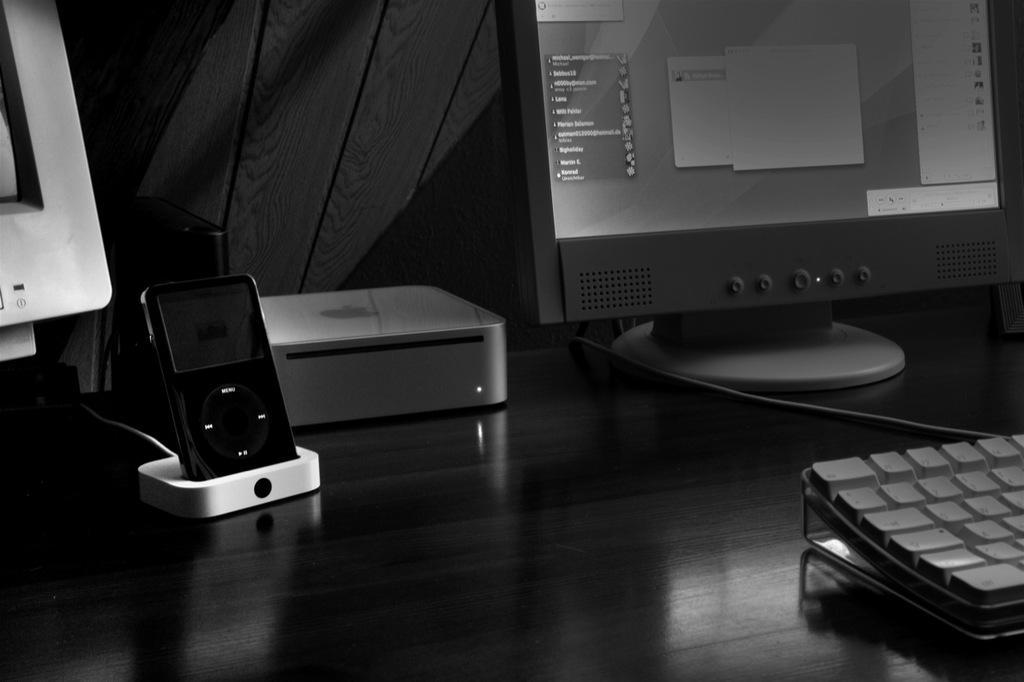Describe this image in one or two sentences. In this image we can see a Apple monitor on the top right corner of the image and in the bottom right corner of the image we can see a keyboard, in middle there is a iPod, on the left to top corner of the image we can see another monitor. 